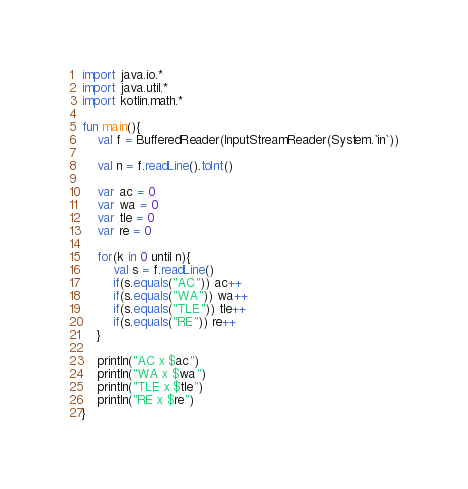Convert code to text. <code><loc_0><loc_0><loc_500><loc_500><_Kotlin_>import java.io.*
import java.util.*
import kotlin.math.*

fun main(){
	val f = BufferedReader(InputStreamReader(System.`in`))

	val n = f.readLine().toInt()

	var ac = 0
	var wa = 0
	var tle = 0
	var re = 0

	for(k in 0 until n){
		val s = f.readLine()
		if(s.equals("AC")) ac++
		if(s.equals("WA")) wa++
		if(s.equals("TLE")) tle++
		if(s.equals("RE")) re++
	}

	println("AC x $ac")
	println("WA x $wa")
	println("TLE x $tle")
	println("RE x $re")
}
</code> 